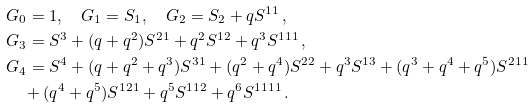Convert formula to latex. <formula><loc_0><loc_0><loc_500><loc_500>& G _ { 0 } = 1 , \quad G _ { 1 } = S _ { 1 } , \quad G _ { 2 } = S _ { 2 } + q S ^ { 1 1 } \, , \\ & G _ { 3 } = S ^ { 3 } + ( q + q ^ { 2 } ) S ^ { 2 1 } + q ^ { 2 } S ^ { 1 2 } + q ^ { 3 } S ^ { 1 1 1 } \, , \\ & G _ { 4 } = S ^ { 4 } + ( q + q ^ { 2 } + q ^ { 3 } ) S ^ { 3 1 } + ( q ^ { 2 } + q ^ { 4 } ) S ^ { 2 2 } + q ^ { 3 } S ^ { 1 3 } + ( q ^ { 3 } + q ^ { 4 } + q ^ { 5 } ) S ^ { 2 1 1 } \\ & \quad + ( q ^ { 4 } + q ^ { 5 } ) S ^ { 1 2 1 } + q ^ { 5 } S ^ { 1 1 2 } + q ^ { 6 } S ^ { 1 1 1 1 } \, .</formula> 